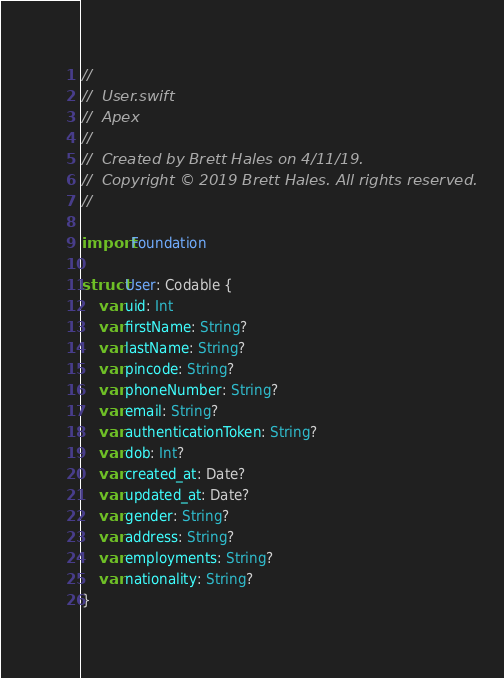<code> <loc_0><loc_0><loc_500><loc_500><_Swift_>//
//  User.swift
//  Apex
//
//  Created by Brett Hales on 4/11/19.
//  Copyright © 2019 Brett Hales. All rights reserved.
//

import Foundation

struct User: Codable {
    var uid: Int
    var firstName: String?
    var lastName: String?
    var pincode: String?
    var phoneNumber: String?
    var email: String?
    var authenticationToken: String?
    var dob: Int?
    var created_at: Date?
    var updated_at: Date?
    var gender: String?
    var address: String?
    var employments: String?
    var nationality: String?
}
</code> 